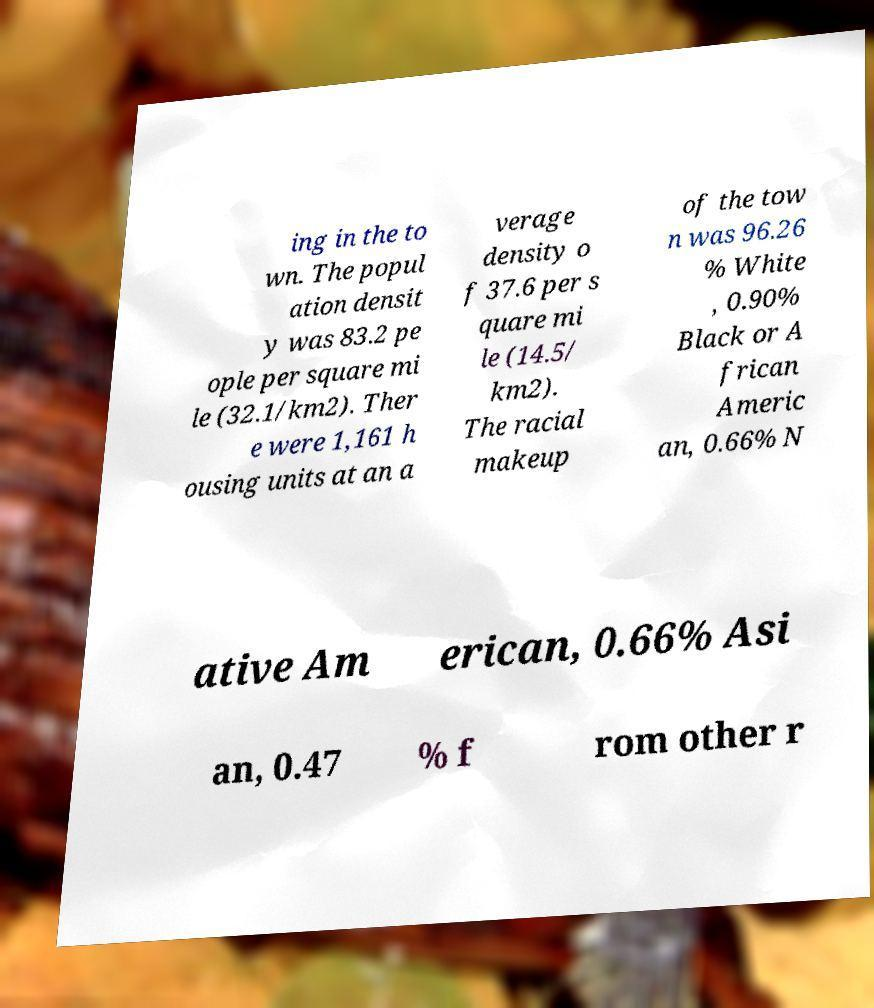Please identify and transcribe the text found in this image. ing in the to wn. The popul ation densit y was 83.2 pe ople per square mi le (32.1/km2). Ther e were 1,161 h ousing units at an a verage density o f 37.6 per s quare mi le (14.5/ km2). The racial makeup of the tow n was 96.26 % White , 0.90% Black or A frican Americ an, 0.66% N ative Am erican, 0.66% Asi an, 0.47 % f rom other r 